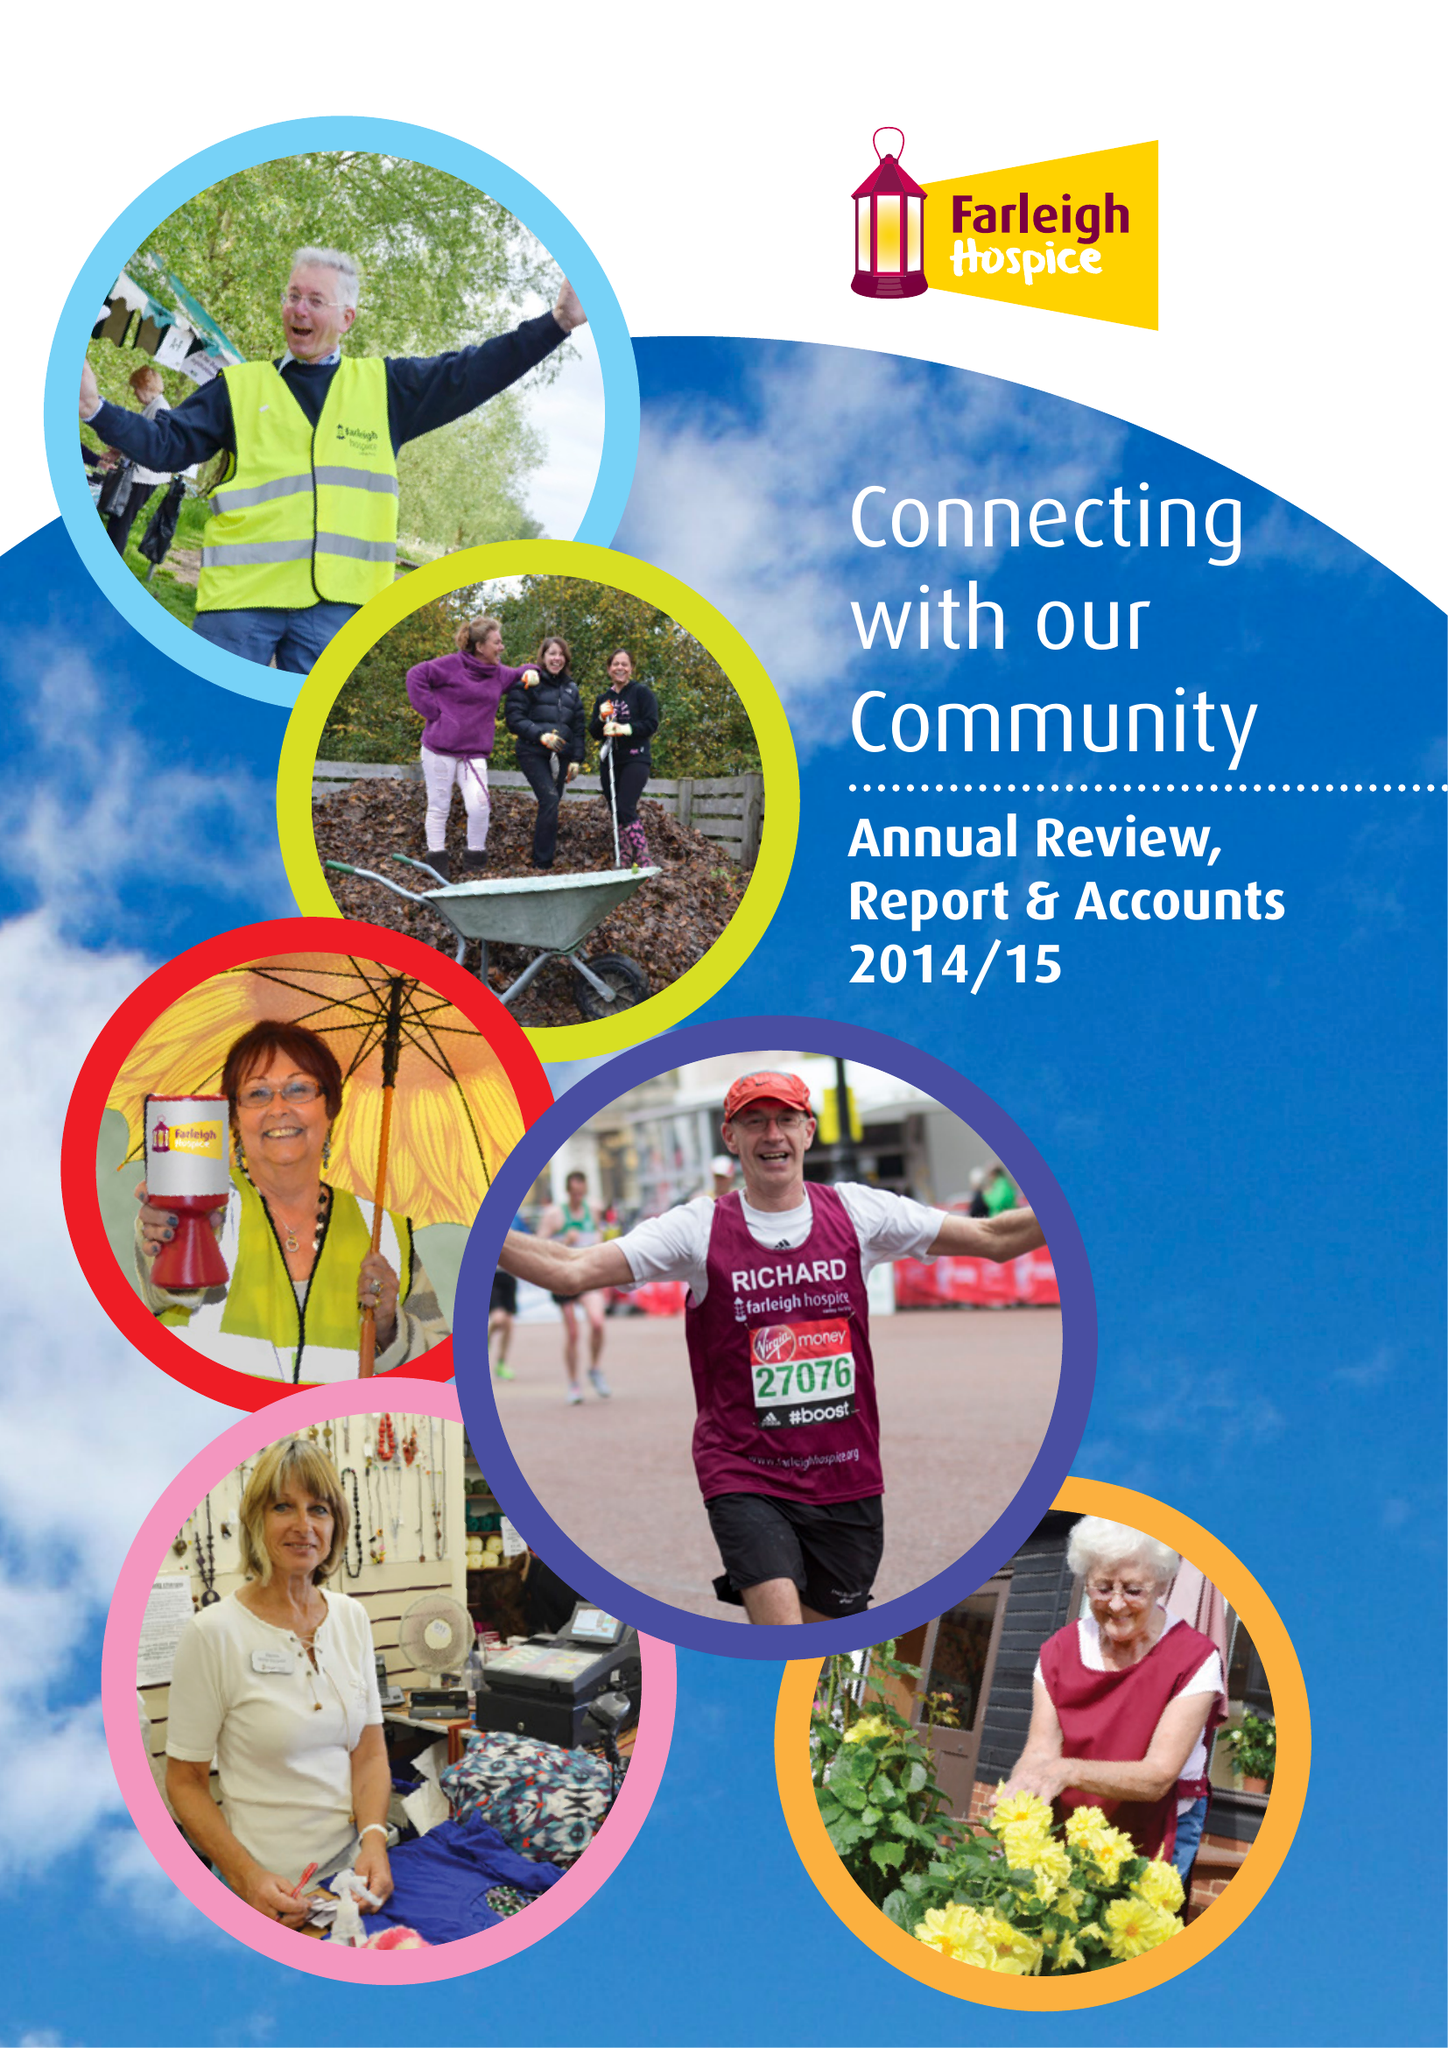What is the value for the address__post_town?
Answer the question using a single word or phrase. CHELMSFORD 